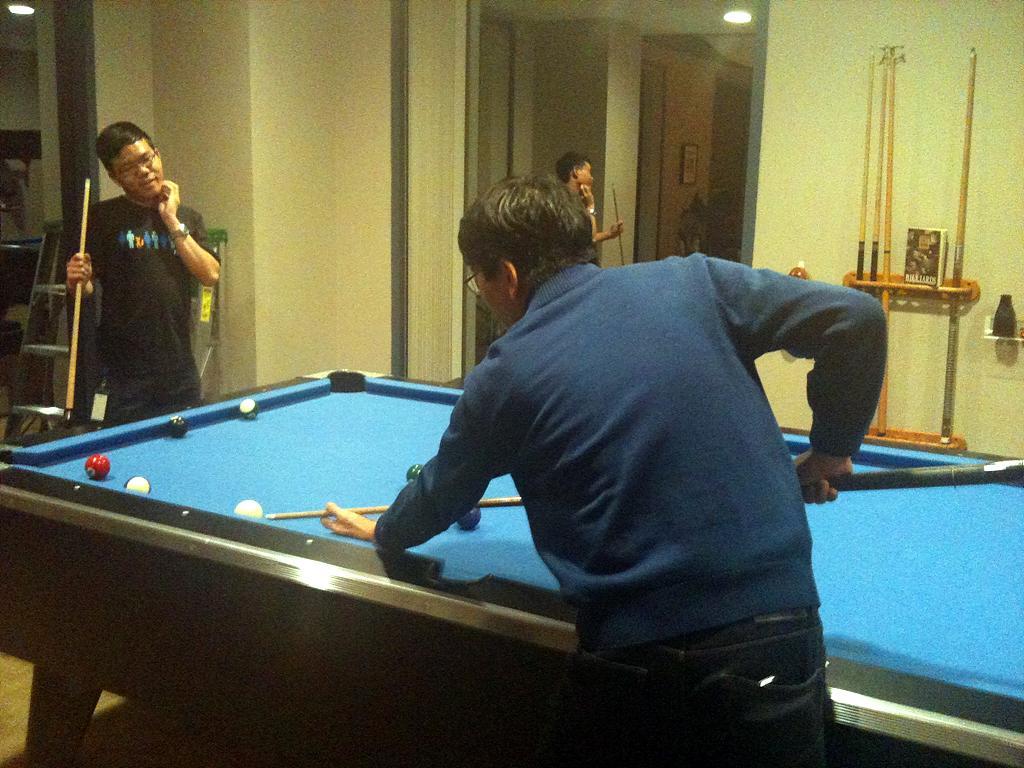In one or two sentences, can you explain what this image depicts? In this picture there is a light on the roof. There is a man who is wearing a black shirt and is holding a stick in his hand. There is a tennis table. In this there are five balls. There is a man who is wearing a blue shirt and is holding the stick and is hitting a ball with the stick. There is also another man who is holding a stick. There is a bottle. There are some sticks in the rack. There is a book. There is a frame on the wall. 